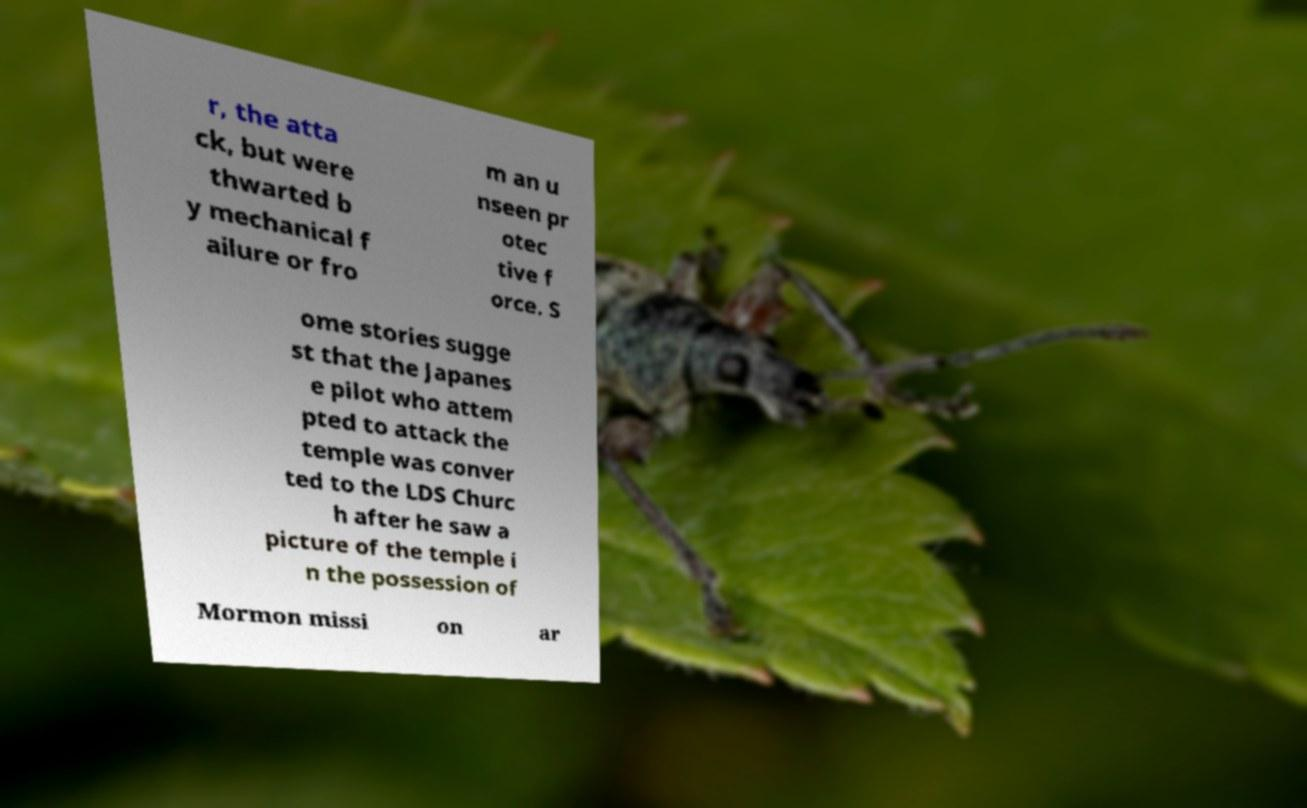Could you extract and type out the text from this image? r, the atta ck, but were thwarted b y mechanical f ailure or fro m an u nseen pr otec tive f orce. S ome stories sugge st that the Japanes e pilot who attem pted to attack the temple was conver ted to the LDS Churc h after he saw a picture of the temple i n the possession of Mormon missi on ar 